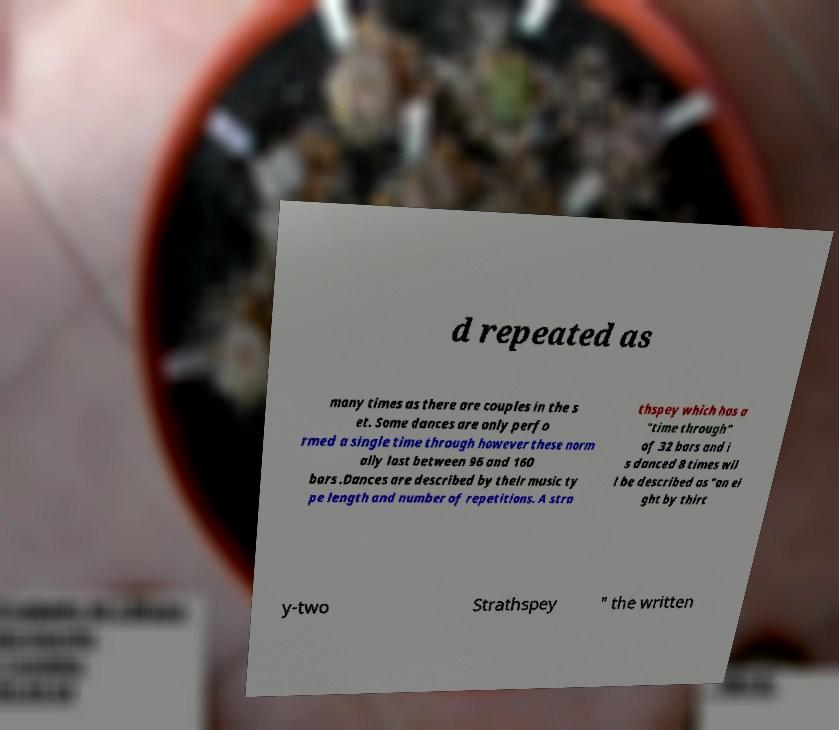What messages or text are displayed in this image? I need them in a readable, typed format. d repeated as many times as there are couples in the s et. Some dances are only perfo rmed a single time through however these norm ally last between 96 and 160 bars .Dances are described by their music ty pe length and number of repetitions. A stra thspey which has a "time through" of 32 bars and i s danced 8 times wil l be described as "an ei ght by thirt y-two Strathspey " the written 